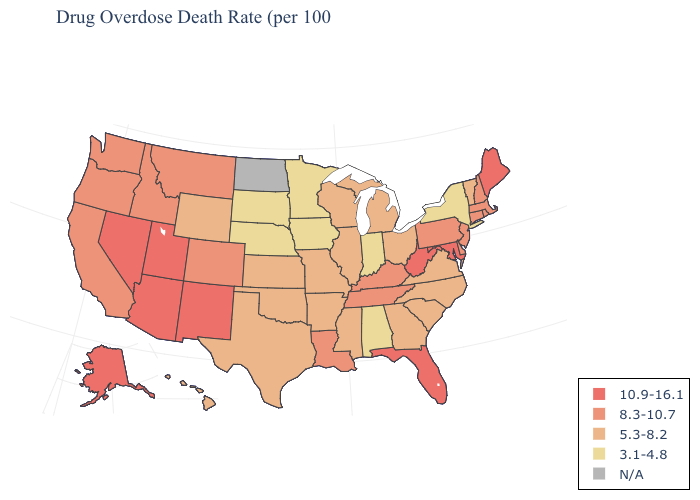What is the highest value in states that border Indiana?
Quick response, please. 8.3-10.7. How many symbols are there in the legend?
Be succinct. 5. Name the states that have a value in the range N/A?
Concise answer only. North Dakota. Name the states that have a value in the range 8.3-10.7?
Write a very short answer. California, Colorado, Connecticut, Delaware, Idaho, Kentucky, Louisiana, Massachusetts, Montana, New Hampshire, New Jersey, Oregon, Pennsylvania, Rhode Island, Tennessee, Washington. Does Georgia have the lowest value in the South?
Short answer required. No. Name the states that have a value in the range 5.3-8.2?
Write a very short answer. Arkansas, Georgia, Hawaii, Illinois, Kansas, Michigan, Mississippi, Missouri, North Carolina, Ohio, Oklahoma, South Carolina, Texas, Vermont, Virginia, Wisconsin, Wyoming. What is the value of South Carolina?
Write a very short answer. 5.3-8.2. Name the states that have a value in the range 5.3-8.2?
Be succinct. Arkansas, Georgia, Hawaii, Illinois, Kansas, Michigan, Mississippi, Missouri, North Carolina, Ohio, Oklahoma, South Carolina, Texas, Vermont, Virginia, Wisconsin, Wyoming. Among the states that border California , does Arizona have the highest value?
Give a very brief answer. Yes. Name the states that have a value in the range N/A?
Write a very short answer. North Dakota. Does the map have missing data?
Write a very short answer. Yes. Which states have the lowest value in the West?
Short answer required. Hawaii, Wyoming. Does Nevada have the lowest value in the West?
Keep it brief. No. Does Maine have the lowest value in the USA?
Quick response, please. No. Does Alaska have the highest value in the USA?
Be succinct. Yes. 